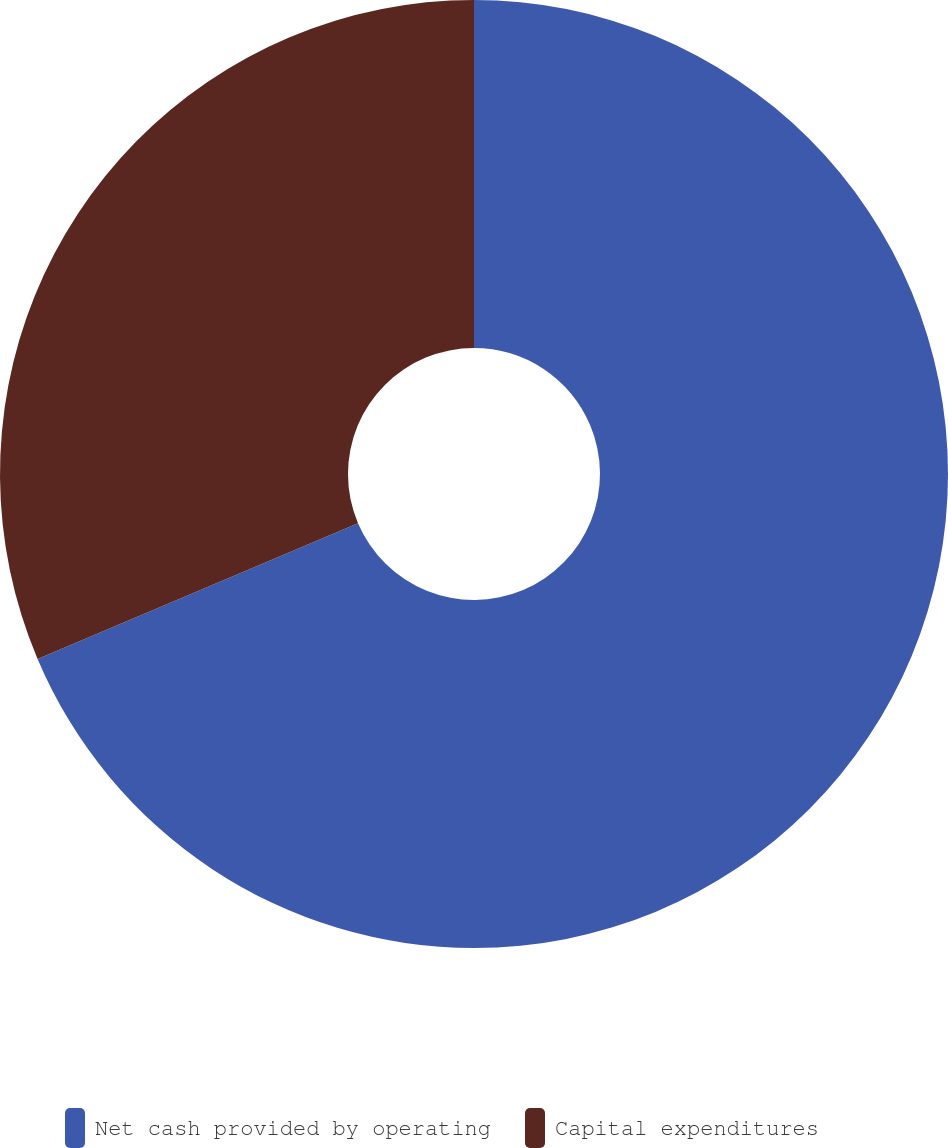Convert chart to OTSL. <chart><loc_0><loc_0><loc_500><loc_500><pie_chart><fcel>Net cash provided by operating<fcel>Capital expenditures<nl><fcel>68.62%<fcel>31.38%<nl></chart> 